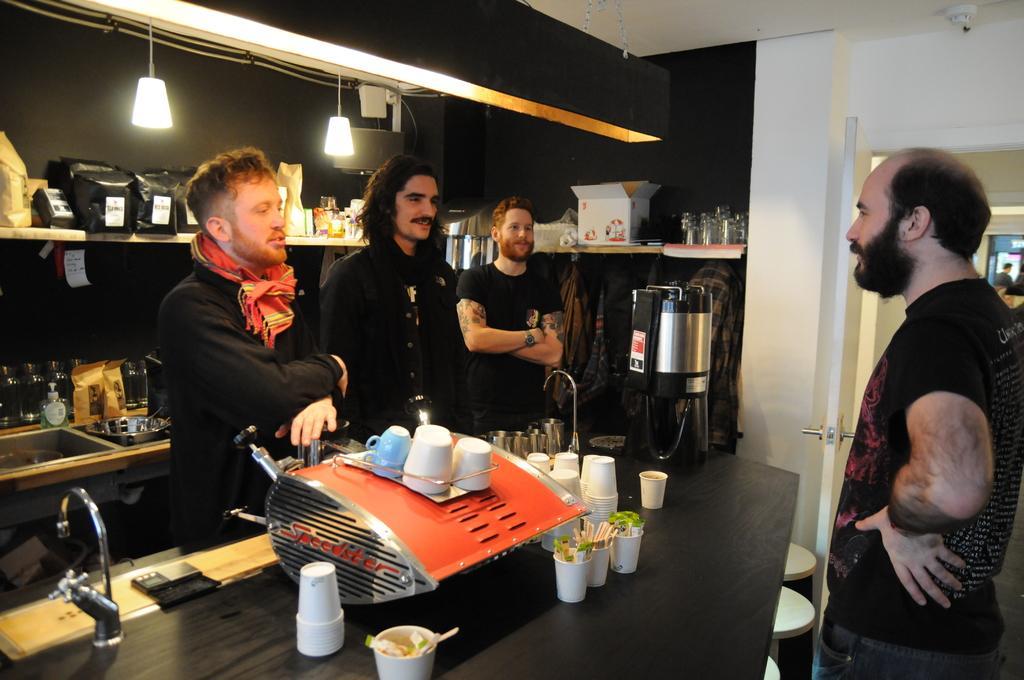How would you summarize this image in a sentence or two? In this image I see 4 men who are wearing black t-shirts and I see that there are few things in this rack and I see a box over here and I see glasses over here and on this table I see the white cups and an equipment over here and I see the tap over here and I see the lights and I see the white and a door over here and I see a there is a thing over here on this ceiling. 